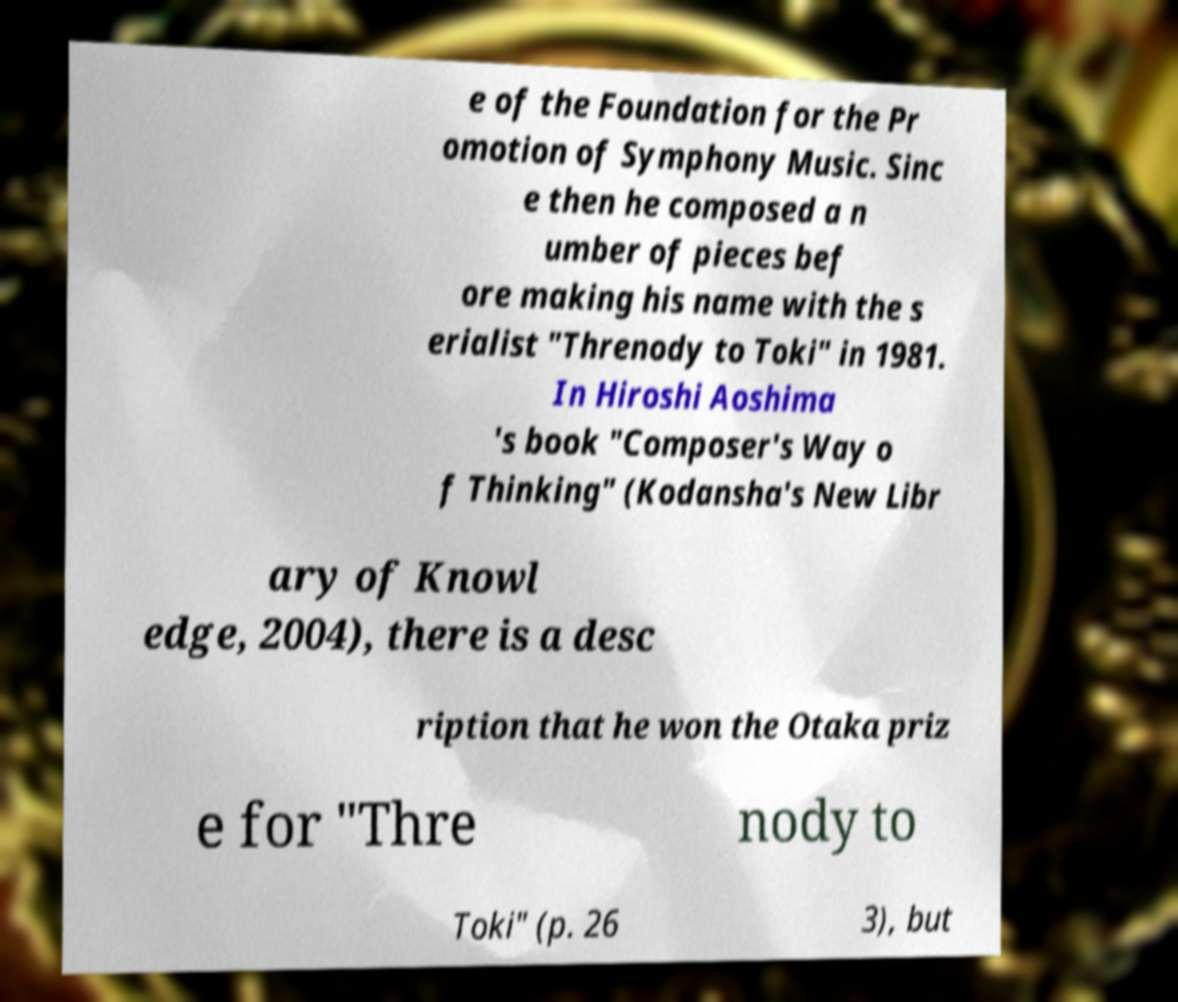Please identify and transcribe the text found in this image. e of the Foundation for the Pr omotion of Symphony Music. Sinc e then he composed a n umber of pieces bef ore making his name with the s erialist "Threnody to Toki" in 1981. In Hiroshi Aoshima 's book "Composer's Way o f Thinking" (Kodansha's New Libr ary of Knowl edge, 2004), there is a desc ription that he won the Otaka priz e for "Thre nody to Toki" (p. 26 3), but 